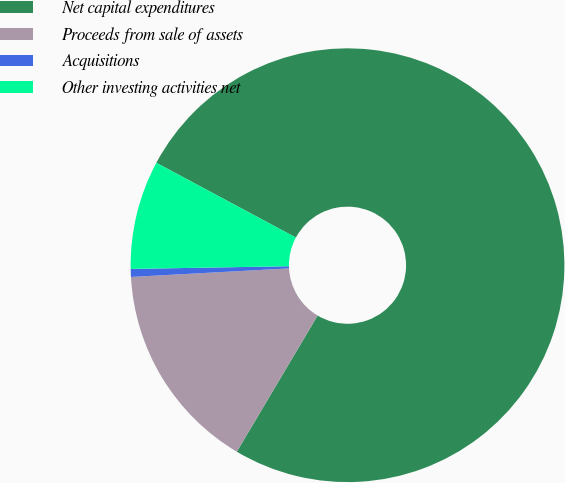Convert chart. <chart><loc_0><loc_0><loc_500><loc_500><pie_chart><fcel>Net capital expenditures<fcel>Proceeds from sale of assets<fcel>Acquisitions<fcel>Other investing activities net<nl><fcel>75.7%<fcel>15.61%<fcel>0.59%<fcel>8.1%<nl></chart> 